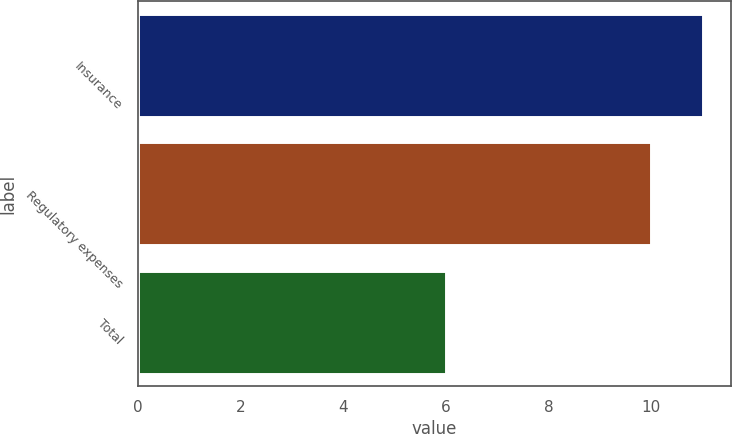Convert chart to OTSL. <chart><loc_0><loc_0><loc_500><loc_500><bar_chart><fcel>Insurance<fcel>Regulatory expenses<fcel>Total<nl><fcel>11<fcel>10<fcel>6<nl></chart> 